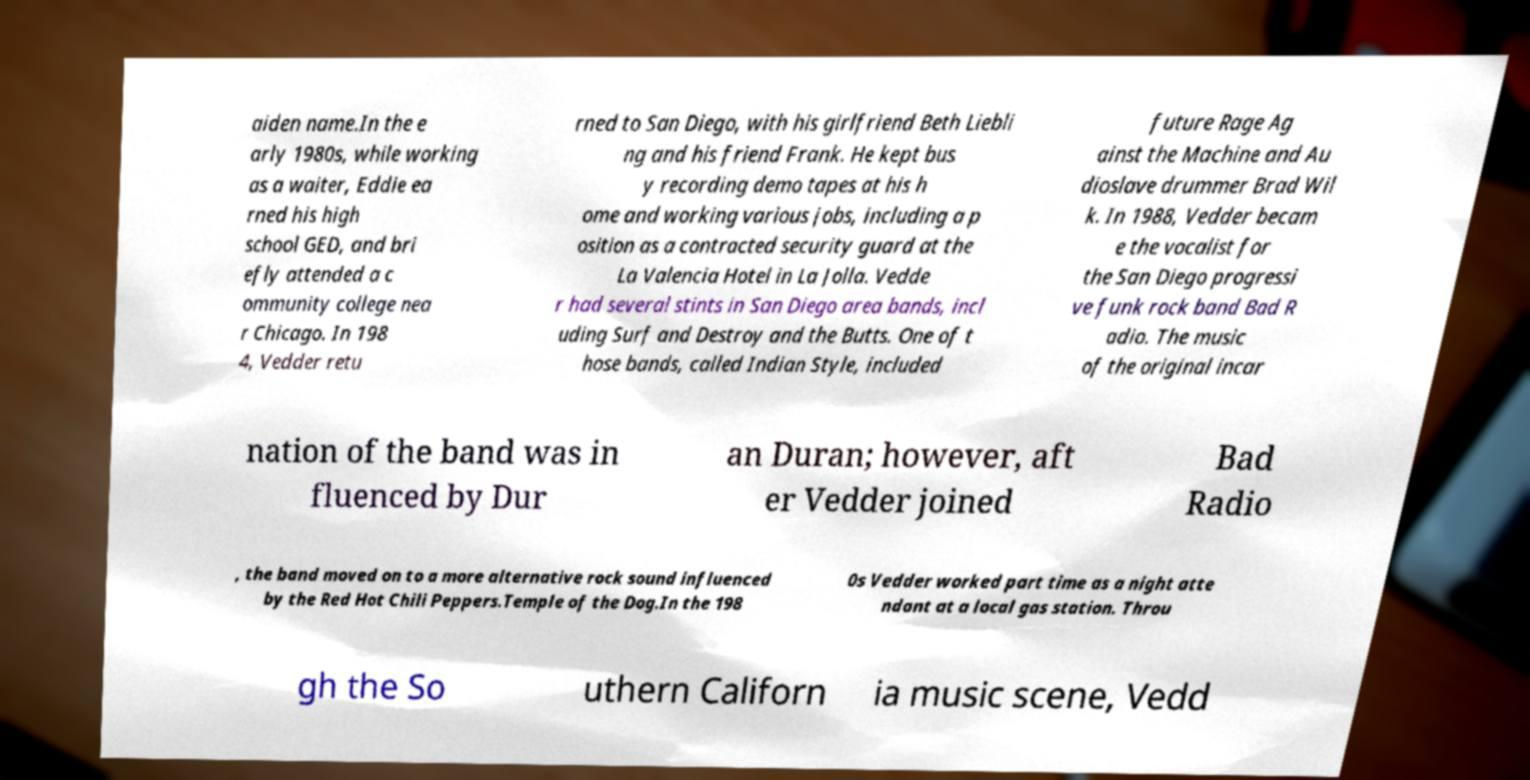Can you accurately transcribe the text from the provided image for me? aiden name.In the e arly 1980s, while working as a waiter, Eddie ea rned his high school GED, and bri efly attended a c ommunity college nea r Chicago. In 198 4, Vedder retu rned to San Diego, with his girlfriend Beth Liebli ng and his friend Frank. He kept bus y recording demo tapes at his h ome and working various jobs, including a p osition as a contracted security guard at the La Valencia Hotel in La Jolla. Vedde r had several stints in San Diego area bands, incl uding Surf and Destroy and the Butts. One of t hose bands, called Indian Style, included future Rage Ag ainst the Machine and Au dioslave drummer Brad Wil k. In 1988, Vedder becam e the vocalist for the San Diego progressi ve funk rock band Bad R adio. The music of the original incar nation of the band was in fluenced by Dur an Duran; however, aft er Vedder joined Bad Radio , the band moved on to a more alternative rock sound influenced by the Red Hot Chili Peppers.Temple of the Dog.In the 198 0s Vedder worked part time as a night atte ndant at a local gas station. Throu gh the So uthern Californ ia music scene, Vedd 